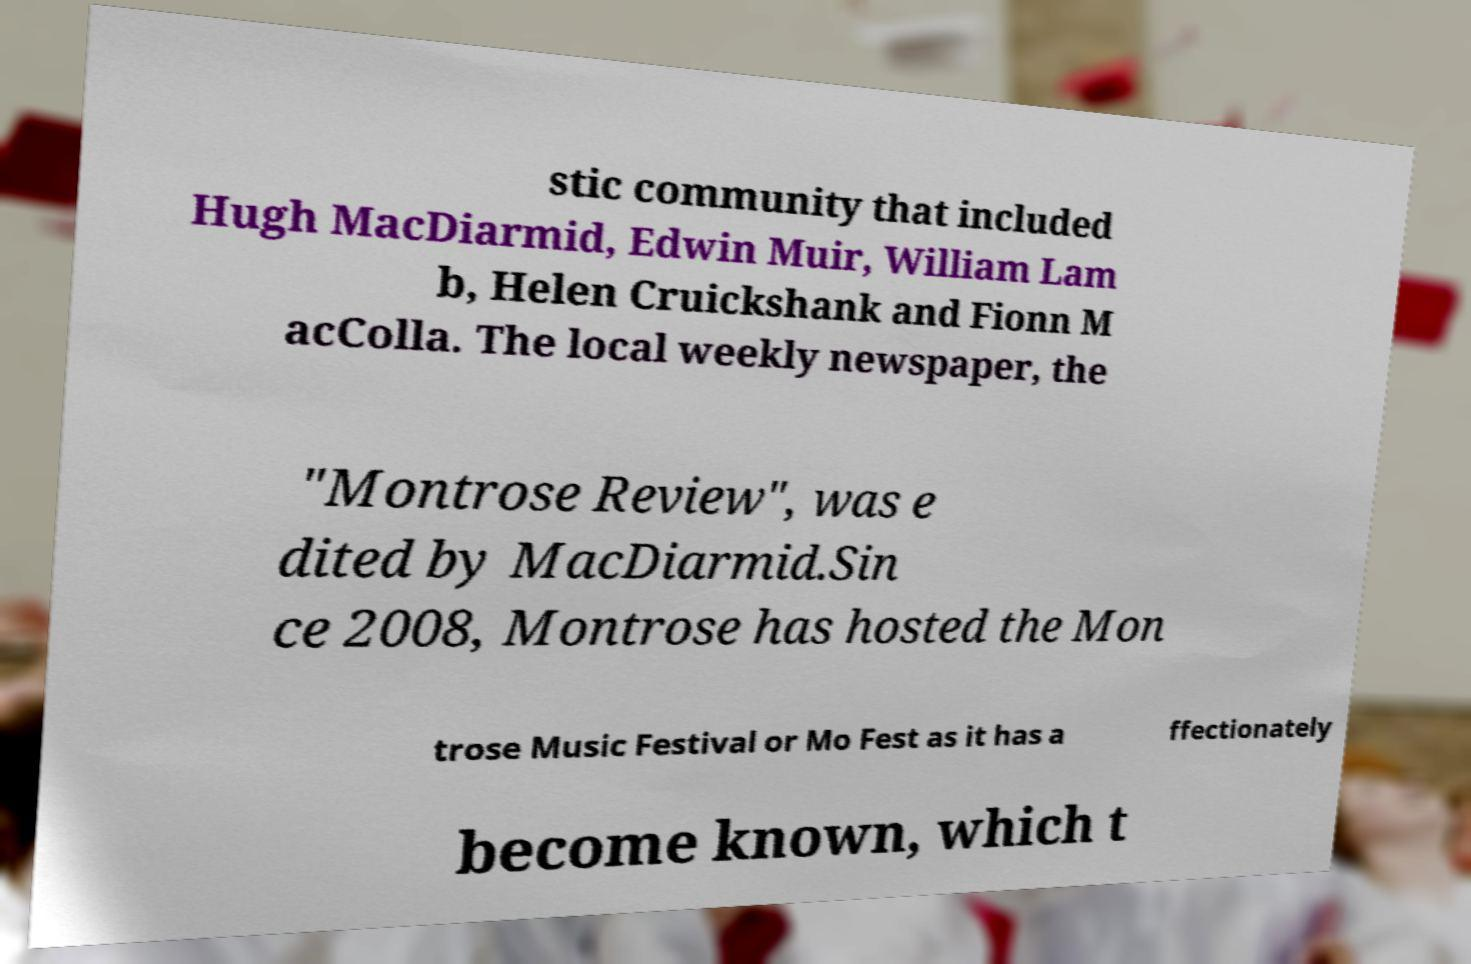Can you read and provide the text displayed in the image?This photo seems to have some interesting text. Can you extract and type it out for me? stic community that included Hugh MacDiarmid, Edwin Muir, William Lam b, Helen Cruickshank and Fionn M acColla. The local weekly newspaper, the "Montrose Review", was e dited by MacDiarmid.Sin ce 2008, Montrose has hosted the Mon trose Music Festival or Mo Fest as it has a ffectionately become known, which t 